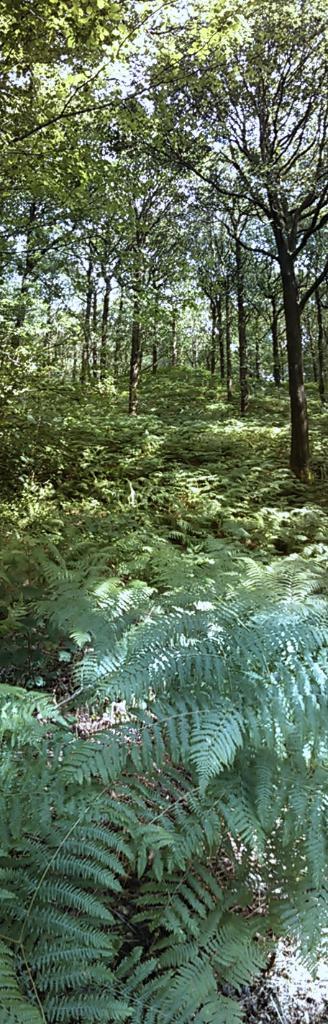In one or two sentences, can you explain what this image depicts? In this picture we can see a few plants and trees in the background. 